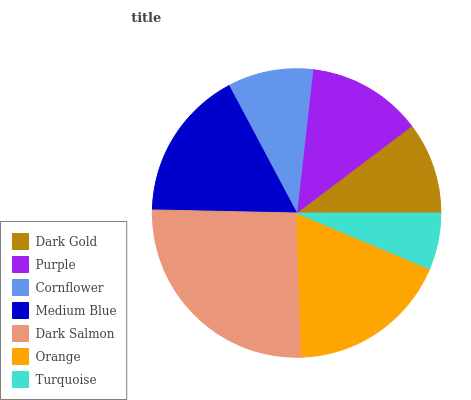Is Turquoise the minimum?
Answer yes or no. Yes. Is Dark Salmon the maximum?
Answer yes or no. Yes. Is Purple the minimum?
Answer yes or no. No. Is Purple the maximum?
Answer yes or no. No. Is Purple greater than Dark Gold?
Answer yes or no. Yes. Is Dark Gold less than Purple?
Answer yes or no. Yes. Is Dark Gold greater than Purple?
Answer yes or no. No. Is Purple less than Dark Gold?
Answer yes or no. No. Is Purple the high median?
Answer yes or no. Yes. Is Purple the low median?
Answer yes or no. Yes. Is Dark Salmon the high median?
Answer yes or no. No. Is Dark Salmon the low median?
Answer yes or no. No. 